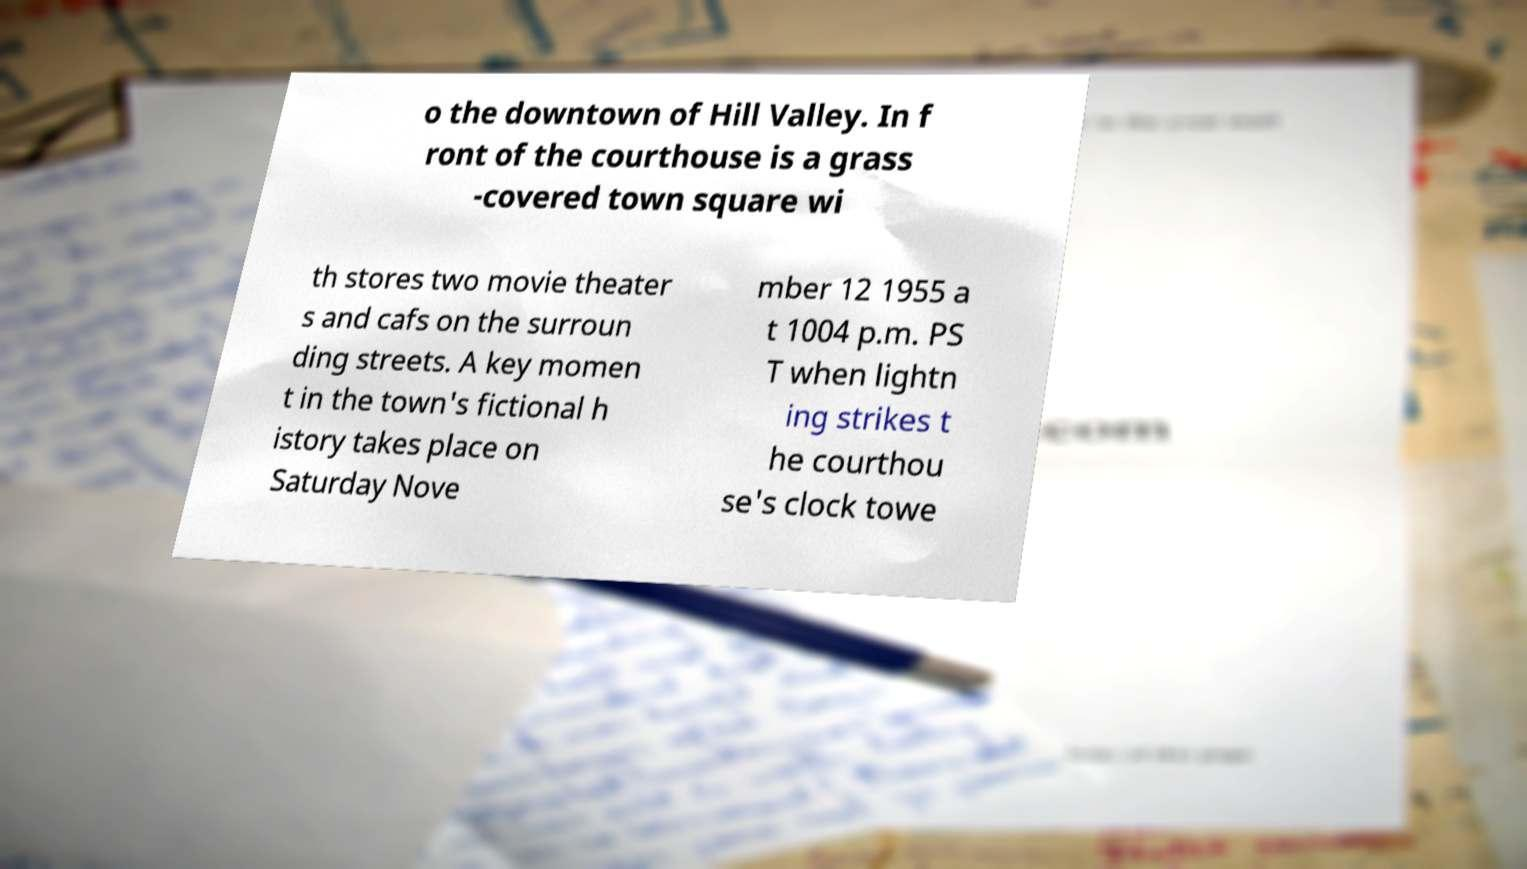Could you assist in decoding the text presented in this image and type it out clearly? o the downtown of Hill Valley. In f ront of the courthouse is a grass -covered town square wi th stores two movie theater s and cafs on the surroun ding streets. A key momen t in the town's fictional h istory takes place on Saturday Nove mber 12 1955 a t 1004 p.m. PS T when lightn ing strikes t he courthou se's clock towe 